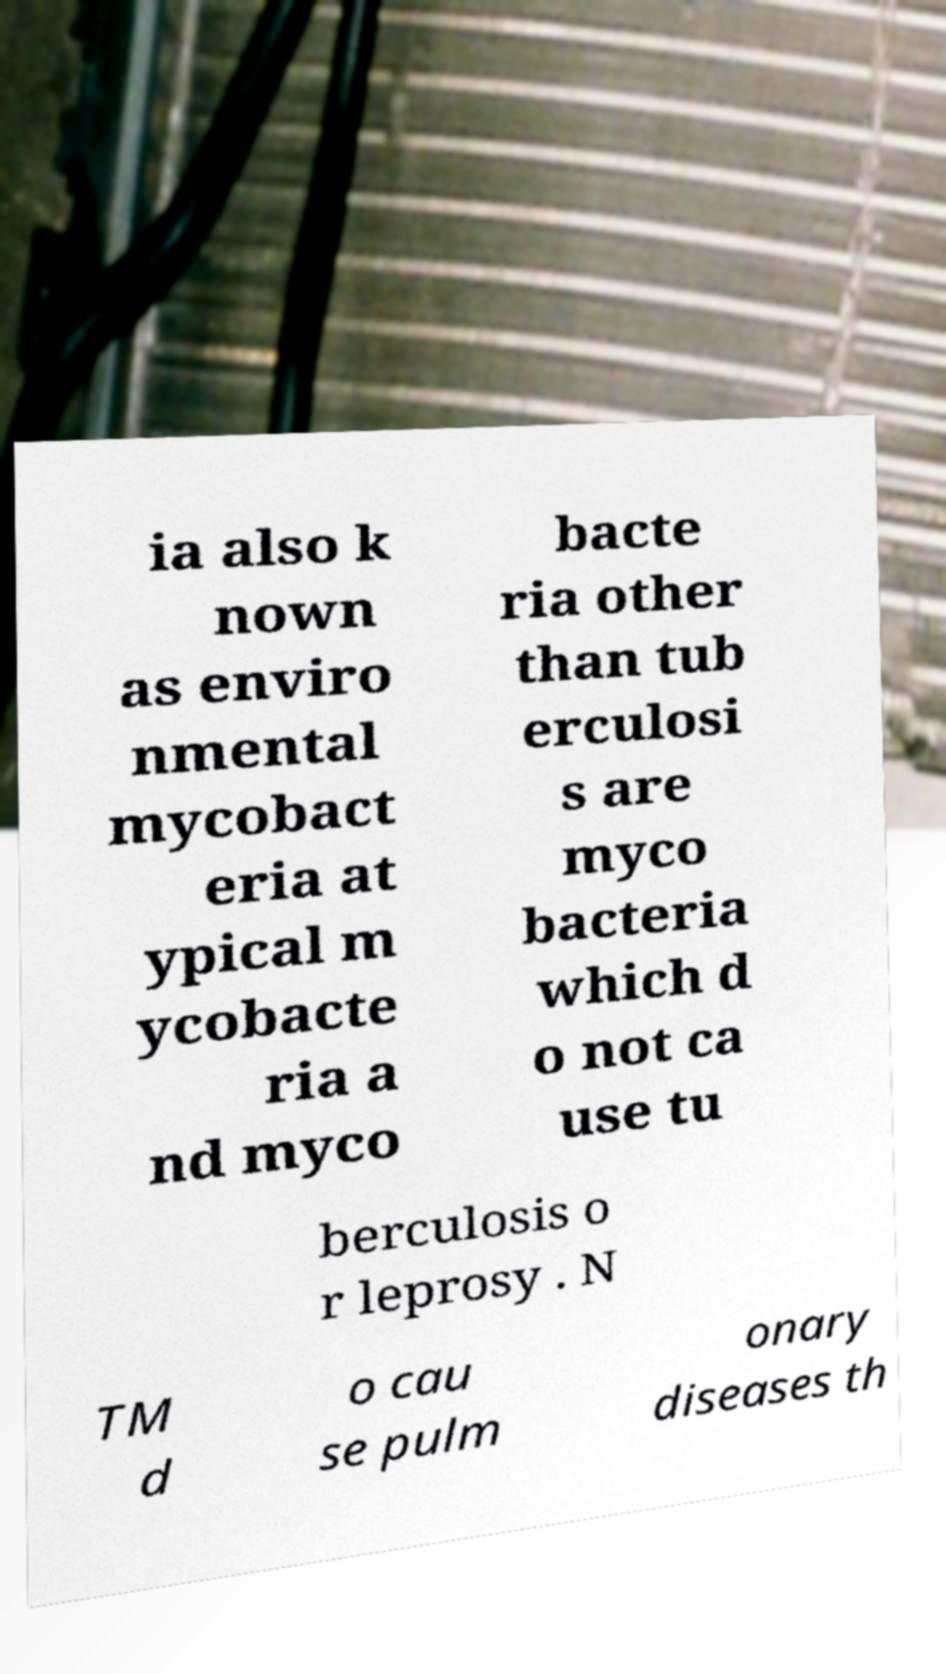Please identify and transcribe the text found in this image. ia also k nown as enviro nmental mycobact eria at ypical m ycobacte ria a nd myco bacte ria other than tub erculosi s are myco bacteria which d o not ca use tu berculosis o r leprosy . N TM d o cau se pulm onary diseases th 